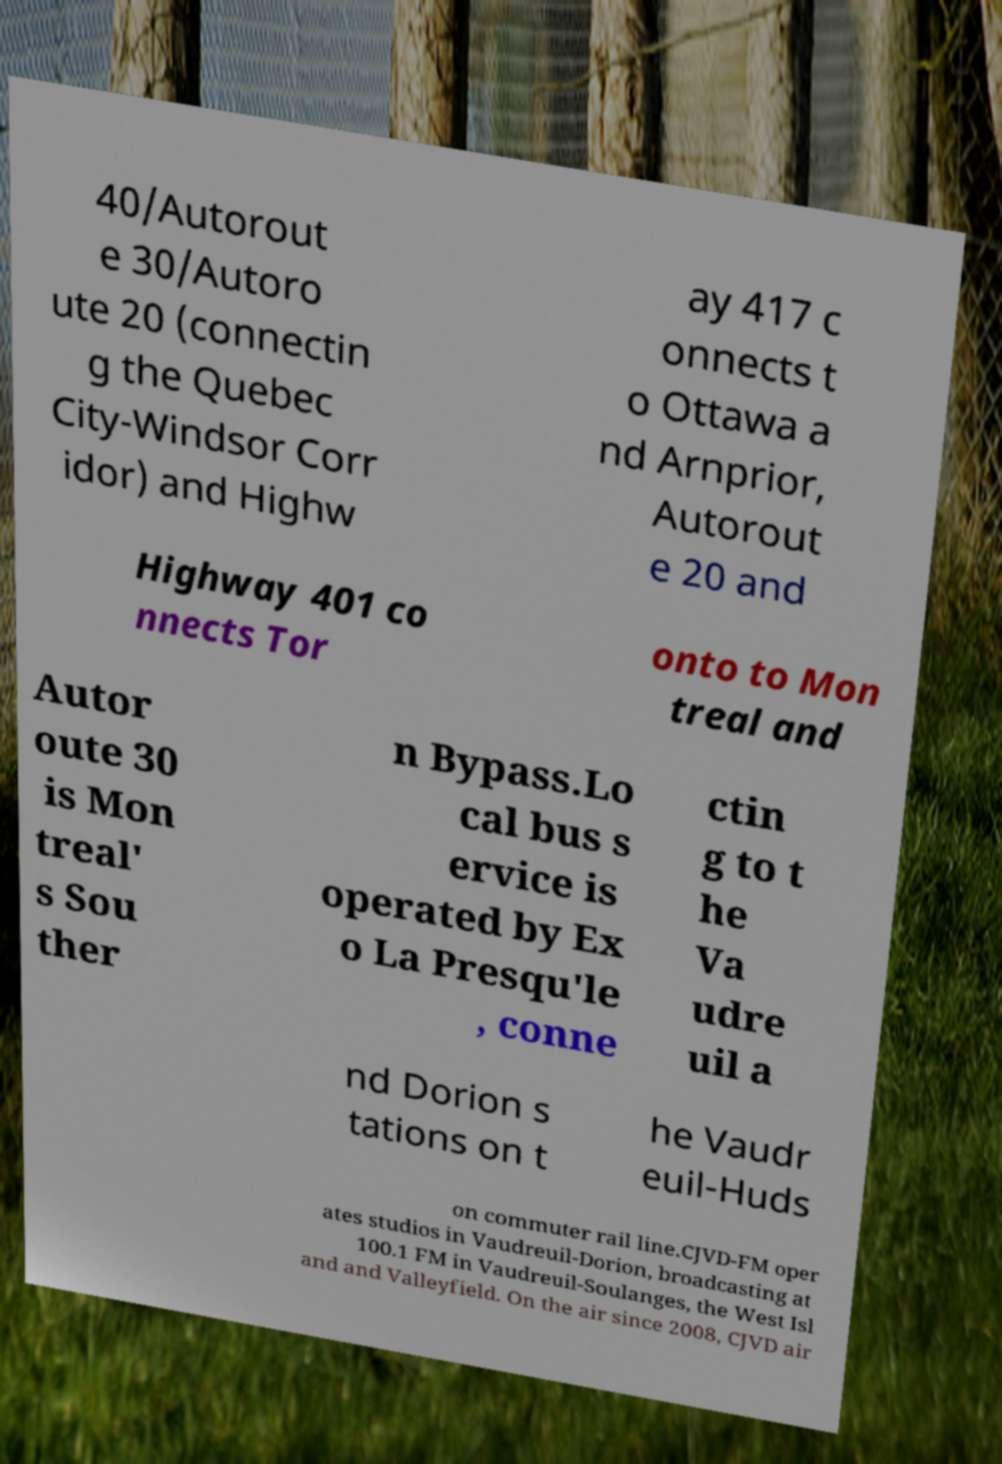Please read and relay the text visible in this image. What does it say? 40/Autorout e 30/Autoro ute 20 (connectin g the Quebec City-Windsor Corr idor) and Highw ay 417 c onnects t o Ottawa a nd Arnprior, Autorout e 20 and Highway 401 co nnects Tor onto to Mon treal and Autor oute 30 is Mon treal' s Sou ther n Bypass.Lo cal bus s ervice is operated by Ex o La Presqu'le , conne ctin g to t he Va udre uil a nd Dorion s tations on t he Vaudr euil-Huds on commuter rail line.CJVD-FM oper ates studios in Vaudreuil-Dorion, broadcasting at 100.1 FM in Vaudreuil-Soulanges, the West Isl and and Valleyfield. On the air since 2008, CJVD air 